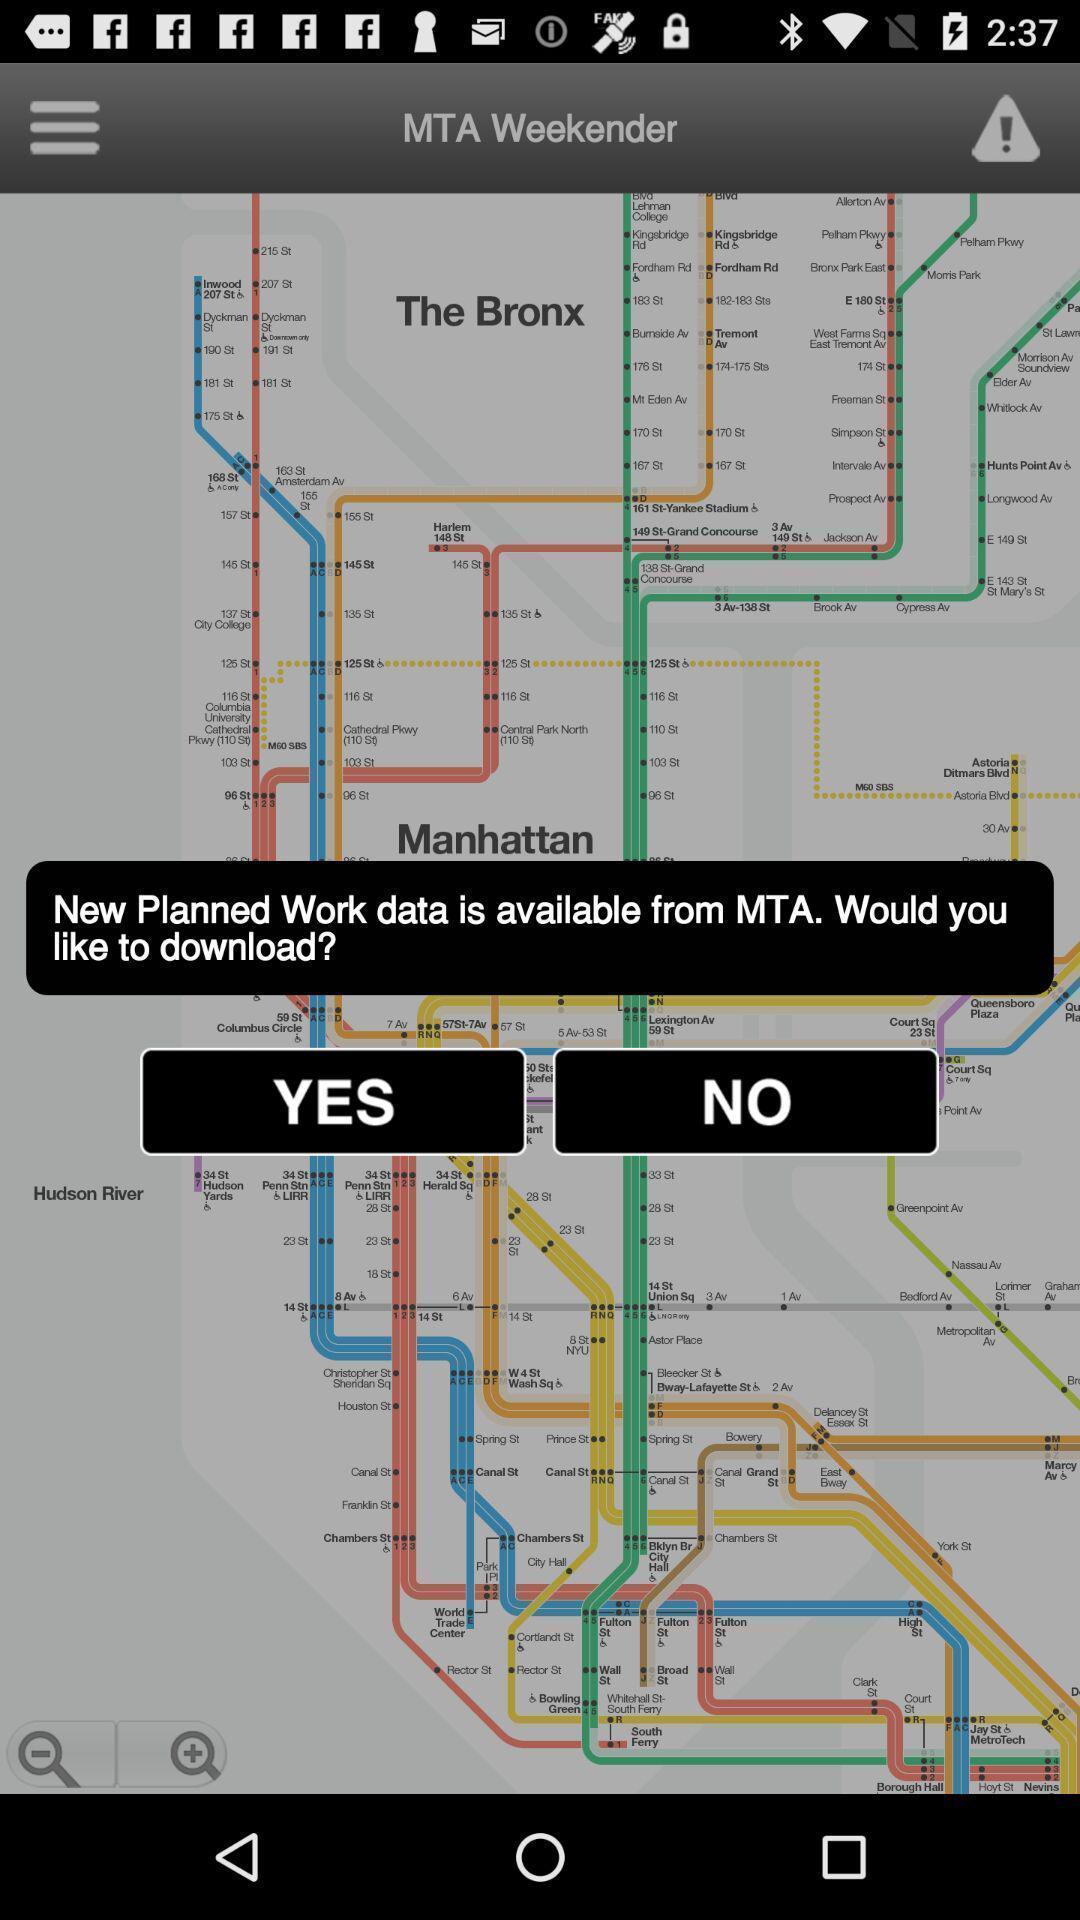Summarize the main components in this picture. Pop-up showing to download transportation app. 